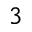Convert formula to latex. <formula><loc_0><loc_0><loc_500><loc_500>^ { 3 }</formula> 